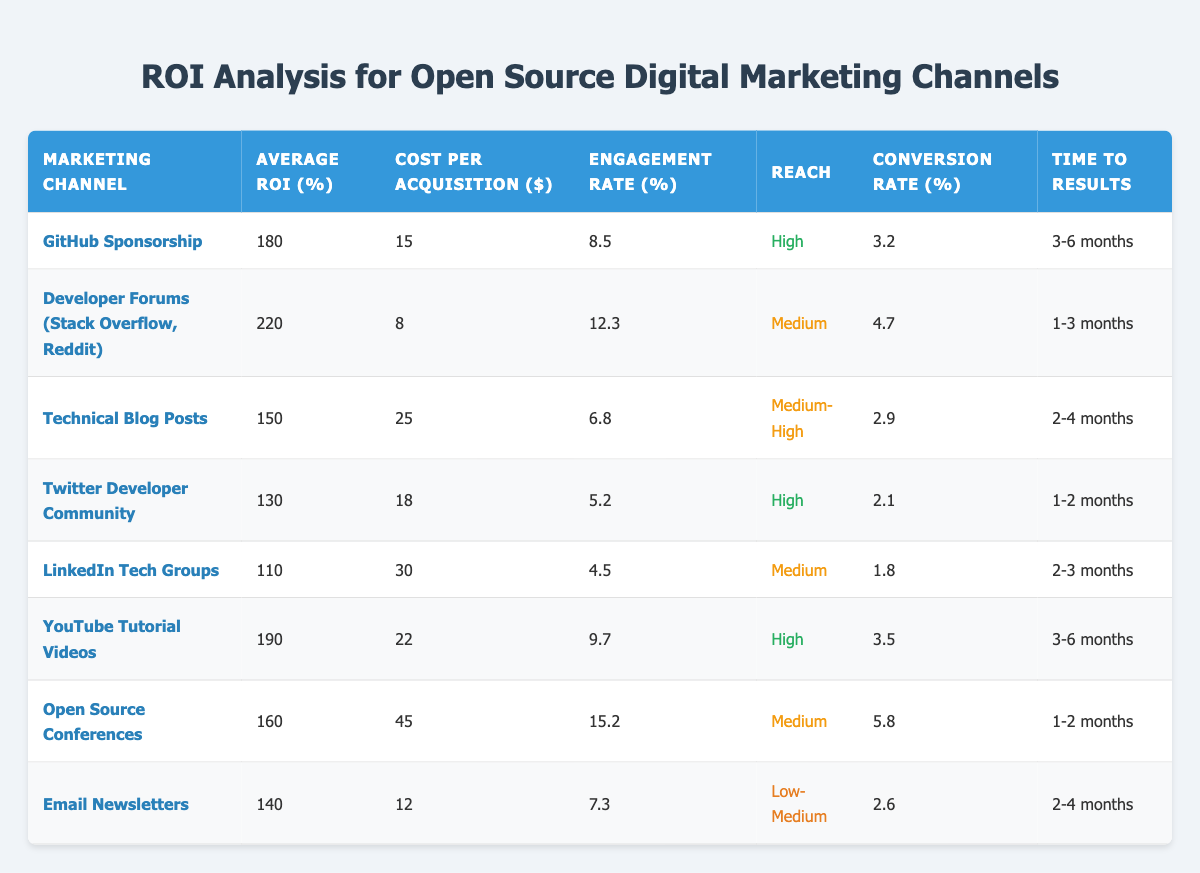What is the highest average ROI from the listed marketing channels? By reviewing the "Average ROI (%)" column, we find that "Developer Forums (Stack Overflow, Reddit)" has the highest average ROI of 220%.
Answer: 220 Which marketing channel has the lowest Cost per Acquisition? Looking at the "Cost per Acquisition ($)" column, "Developer Forums (Stack Overflow, Reddit)" has the lowest cost at $8.
Answer: $8 What is the average engagement rate across all marketing channels? To calculate the average engagement rate, we sum the engagement rates: (8.5 + 12.3 + 6.8 + 5.2 + 4.5 + 9.7 + 15.2 + 7.3) = 69.5 and divide by the number of channels (8), resulting in an average of 69.5 / 8 = 8.6875.
Answer: 8.69 Is the conversion rate for YouTube Tutorial Videos higher than that for Email Newsletters? The conversion rates are compared: YouTube Tutorial Videos have a conversion rate of 3.5%, while Email Newsletters have 2.6%. Since 3.5% is greater than 2.6%, the answer is yes.
Answer: Yes How is the time to results for Open Source Conferences in comparison to Technical Blog Posts? Referencing the "Time to Results" column, we see that Open Source Conferences take 1-2 months while Technical Blog Posts take 2-4 months. Thus, Open Source Conferences have a shorter time to results.
Answer: Shorter What is the average ROI of Technical Blog Posts and Twitter Developer Community combined? The average ROI for both channels is calculated by summing their ROIs: (150 + 130) = 280. Dividing by 2, we get 280 / 2 = 140.
Answer: 140 Which marketing channel has the highest engagement rate? By checking all values in the "Engagement Rate (%)" column, we find that "Open Source Conferences" holds the highest engagement rate at 15.2%.
Answer: 15.2 Is it true that LinkedIn Tech Groups have a higher conversion rate than GitHub Sponsorship? Comparing the conversion rates: LinkedIn Tech Groups have 1.8% while GitHub Sponsorship has 3.2%. Since 1.8% is less than 3.2%, the statement is false.
Answer: No What is the difference in cost per acquisition between the Developer Forums and Email Newsletters? The cost per acquisition for Developer Forums is $8 and for Email Newsletters is $12. Subtracting these gives us: 12 - 8 = 4, indicating Email Newsletters cost $4 more.
Answer: $4 